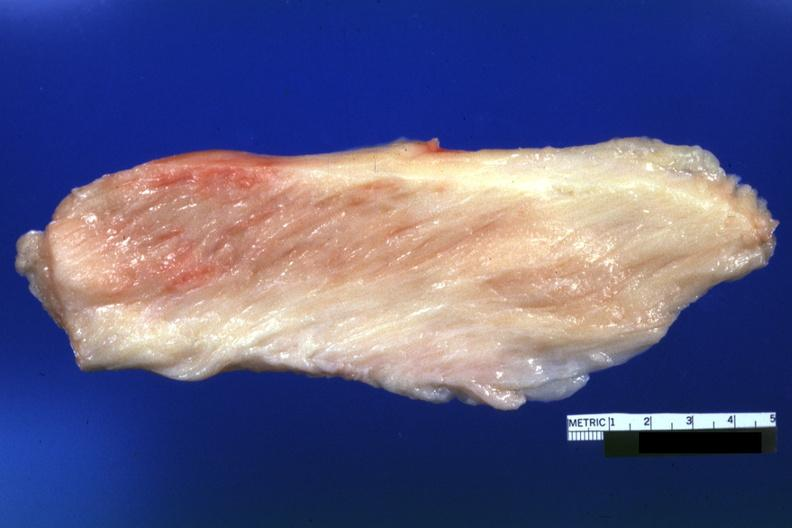what is present?
Answer the question using a single word or phrase. Soft tissue 